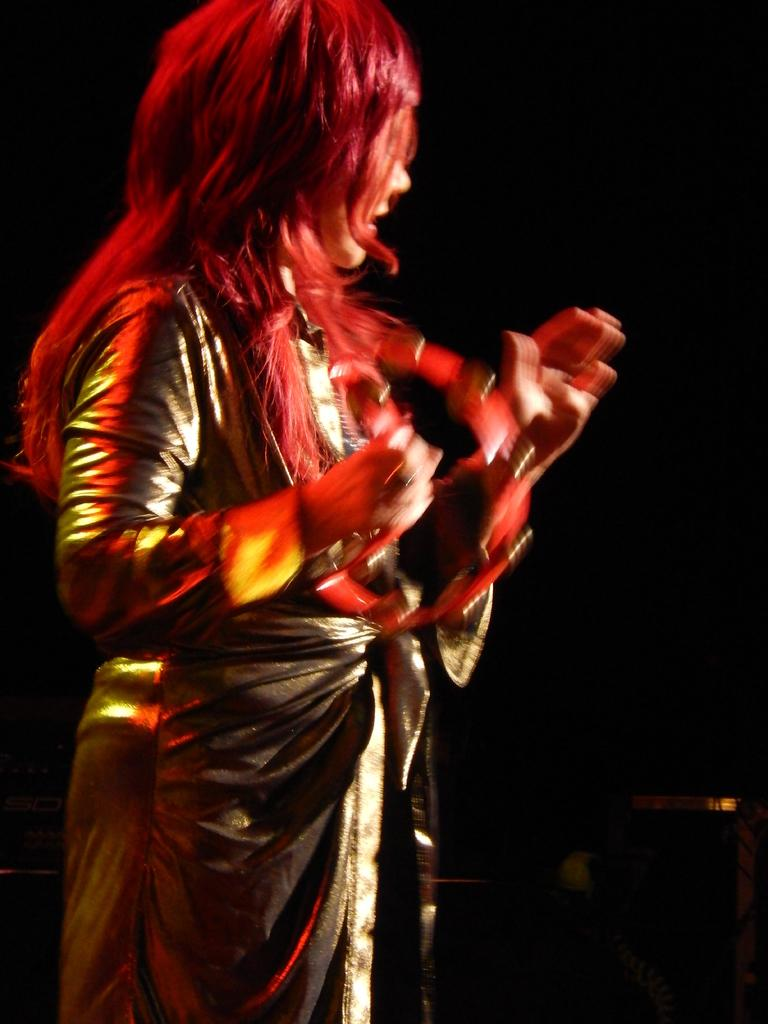What is the main subject of the image? There is a person standing in the image. What can be seen behind the person in the image? The background of the image is black. How many clocks are hanging on the scarecrow in the image? There is no scarecrow or clocks present in the image. 